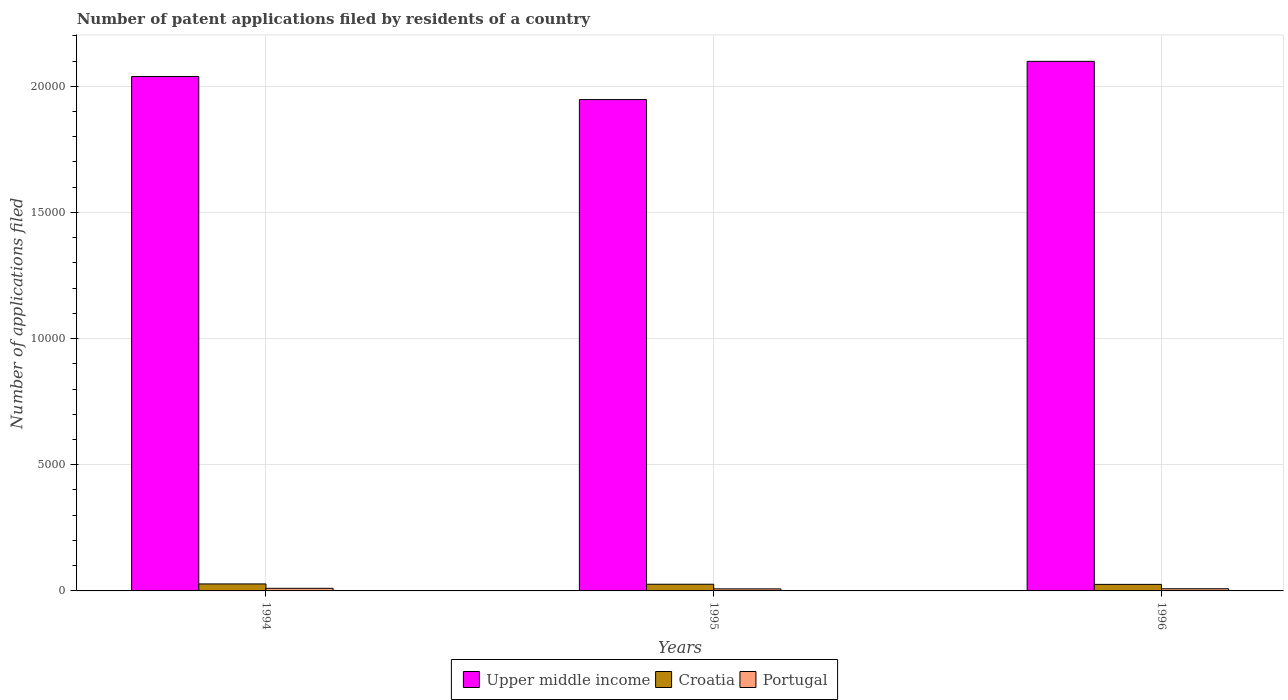Are the number of bars on each tick of the X-axis equal?
Provide a succinct answer. Yes. How many bars are there on the 3rd tick from the left?
Your answer should be very brief. 3. How many bars are there on the 1st tick from the right?
Give a very brief answer. 3. In how many cases, is the number of bars for a given year not equal to the number of legend labels?
Keep it short and to the point. 0. What is the number of applications filed in Croatia in 1996?
Ensure brevity in your answer.  259. Across all years, what is the maximum number of applications filed in Croatia?
Your answer should be very brief. 277. Across all years, what is the minimum number of applications filed in Croatia?
Your answer should be compact. 259. In which year was the number of applications filed in Portugal maximum?
Your answer should be very brief. 1994. What is the total number of applications filed in Portugal in the graph?
Offer a very short reply. 270. What is the difference between the number of applications filed in Upper middle income in 1994 and that in 1996?
Keep it short and to the point. -602. What is the difference between the number of applications filed in Upper middle income in 1994 and the number of applications filed in Portugal in 1995?
Your answer should be compact. 2.03e+04. What is the average number of applications filed in Upper middle income per year?
Offer a very short reply. 2.03e+04. In the year 1996, what is the difference between the number of applications filed in Portugal and number of applications filed in Croatia?
Make the answer very short. -173. In how many years, is the number of applications filed in Upper middle income greater than 8000?
Your answer should be compact. 3. What is the ratio of the number of applications filed in Portugal in 1995 to that in 1996?
Give a very brief answer. 0.94. Is the number of applications filed in Portugal in 1994 less than that in 1996?
Offer a terse response. No. What is the difference between the highest and the lowest number of applications filed in Upper middle income?
Ensure brevity in your answer.  1515. In how many years, is the number of applications filed in Croatia greater than the average number of applications filed in Croatia taken over all years?
Make the answer very short. 1. What does the 2nd bar from the left in 1995 represents?
Your answer should be compact. Croatia. What does the 1st bar from the right in 1994 represents?
Your answer should be very brief. Portugal. Are all the bars in the graph horizontal?
Your answer should be very brief. No. Are the values on the major ticks of Y-axis written in scientific E-notation?
Your answer should be very brief. No. Does the graph contain any zero values?
Ensure brevity in your answer.  No. What is the title of the graph?
Your response must be concise. Number of patent applications filed by residents of a country. What is the label or title of the Y-axis?
Your answer should be compact. Number of applications filed. What is the Number of applications filed in Upper middle income in 1994?
Give a very brief answer. 2.04e+04. What is the Number of applications filed in Croatia in 1994?
Keep it short and to the point. 277. What is the Number of applications filed in Portugal in 1994?
Keep it short and to the point. 103. What is the Number of applications filed in Upper middle income in 1995?
Offer a terse response. 1.95e+04. What is the Number of applications filed in Croatia in 1995?
Ensure brevity in your answer.  265. What is the Number of applications filed of Upper middle income in 1996?
Ensure brevity in your answer.  2.10e+04. What is the Number of applications filed in Croatia in 1996?
Make the answer very short. 259. What is the Number of applications filed of Portugal in 1996?
Your answer should be compact. 86. Across all years, what is the maximum Number of applications filed of Upper middle income?
Your answer should be very brief. 2.10e+04. Across all years, what is the maximum Number of applications filed of Croatia?
Keep it short and to the point. 277. Across all years, what is the maximum Number of applications filed in Portugal?
Your answer should be very brief. 103. Across all years, what is the minimum Number of applications filed in Upper middle income?
Offer a very short reply. 1.95e+04. Across all years, what is the minimum Number of applications filed of Croatia?
Your answer should be compact. 259. Across all years, what is the minimum Number of applications filed in Portugal?
Make the answer very short. 81. What is the total Number of applications filed of Upper middle income in the graph?
Ensure brevity in your answer.  6.08e+04. What is the total Number of applications filed of Croatia in the graph?
Make the answer very short. 801. What is the total Number of applications filed of Portugal in the graph?
Your answer should be compact. 270. What is the difference between the Number of applications filed in Upper middle income in 1994 and that in 1995?
Your answer should be compact. 913. What is the difference between the Number of applications filed in Croatia in 1994 and that in 1995?
Your answer should be compact. 12. What is the difference between the Number of applications filed of Portugal in 1994 and that in 1995?
Offer a terse response. 22. What is the difference between the Number of applications filed in Upper middle income in 1994 and that in 1996?
Give a very brief answer. -602. What is the difference between the Number of applications filed of Croatia in 1994 and that in 1996?
Provide a succinct answer. 18. What is the difference between the Number of applications filed in Upper middle income in 1995 and that in 1996?
Provide a succinct answer. -1515. What is the difference between the Number of applications filed in Portugal in 1995 and that in 1996?
Your answer should be very brief. -5. What is the difference between the Number of applications filed in Upper middle income in 1994 and the Number of applications filed in Croatia in 1995?
Offer a very short reply. 2.01e+04. What is the difference between the Number of applications filed in Upper middle income in 1994 and the Number of applications filed in Portugal in 1995?
Your answer should be very brief. 2.03e+04. What is the difference between the Number of applications filed in Croatia in 1994 and the Number of applications filed in Portugal in 1995?
Offer a terse response. 196. What is the difference between the Number of applications filed in Upper middle income in 1994 and the Number of applications filed in Croatia in 1996?
Offer a very short reply. 2.01e+04. What is the difference between the Number of applications filed of Upper middle income in 1994 and the Number of applications filed of Portugal in 1996?
Your answer should be very brief. 2.03e+04. What is the difference between the Number of applications filed in Croatia in 1994 and the Number of applications filed in Portugal in 1996?
Give a very brief answer. 191. What is the difference between the Number of applications filed in Upper middle income in 1995 and the Number of applications filed in Croatia in 1996?
Ensure brevity in your answer.  1.92e+04. What is the difference between the Number of applications filed in Upper middle income in 1995 and the Number of applications filed in Portugal in 1996?
Ensure brevity in your answer.  1.94e+04. What is the difference between the Number of applications filed of Croatia in 1995 and the Number of applications filed of Portugal in 1996?
Make the answer very short. 179. What is the average Number of applications filed of Upper middle income per year?
Keep it short and to the point. 2.03e+04. What is the average Number of applications filed in Croatia per year?
Provide a succinct answer. 267. What is the average Number of applications filed in Portugal per year?
Make the answer very short. 90. In the year 1994, what is the difference between the Number of applications filed of Upper middle income and Number of applications filed of Croatia?
Your answer should be very brief. 2.01e+04. In the year 1994, what is the difference between the Number of applications filed of Upper middle income and Number of applications filed of Portugal?
Your answer should be very brief. 2.03e+04. In the year 1994, what is the difference between the Number of applications filed in Croatia and Number of applications filed in Portugal?
Make the answer very short. 174. In the year 1995, what is the difference between the Number of applications filed of Upper middle income and Number of applications filed of Croatia?
Provide a short and direct response. 1.92e+04. In the year 1995, what is the difference between the Number of applications filed in Upper middle income and Number of applications filed in Portugal?
Make the answer very short. 1.94e+04. In the year 1995, what is the difference between the Number of applications filed of Croatia and Number of applications filed of Portugal?
Offer a very short reply. 184. In the year 1996, what is the difference between the Number of applications filed in Upper middle income and Number of applications filed in Croatia?
Provide a short and direct response. 2.07e+04. In the year 1996, what is the difference between the Number of applications filed of Upper middle income and Number of applications filed of Portugal?
Your answer should be very brief. 2.09e+04. In the year 1996, what is the difference between the Number of applications filed of Croatia and Number of applications filed of Portugal?
Give a very brief answer. 173. What is the ratio of the Number of applications filed in Upper middle income in 1994 to that in 1995?
Keep it short and to the point. 1.05. What is the ratio of the Number of applications filed in Croatia in 1994 to that in 1995?
Keep it short and to the point. 1.05. What is the ratio of the Number of applications filed of Portugal in 1994 to that in 1995?
Make the answer very short. 1.27. What is the ratio of the Number of applications filed of Upper middle income in 1994 to that in 1996?
Your answer should be compact. 0.97. What is the ratio of the Number of applications filed in Croatia in 1994 to that in 1996?
Give a very brief answer. 1.07. What is the ratio of the Number of applications filed in Portugal in 1994 to that in 1996?
Give a very brief answer. 1.2. What is the ratio of the Number of applications filed of Upper middle income in 1995 to that in 1996?
Your answer should be compact. 0.93. What is the ratio of the Number of applications filed in Croatia in 1995 to that in 1996?
Make the answer very short. 1.02. What is the ratio of the Number of applications filed in Portugal in 1995 to that in 1996?
Ensure brevity in your answer.  0.94. What is the difference between the highest and the second highest Number of applications filed in Upper middle income?
Your answer should be compact. 602. What is the difference between the highest and the second highest Number of applications filed of Croatia?
Your answer should be very brief. 12. What is the difference between the highest and the lowest Number of applications filed in Upper middle income?
Provide a succinct answer. 1515. 